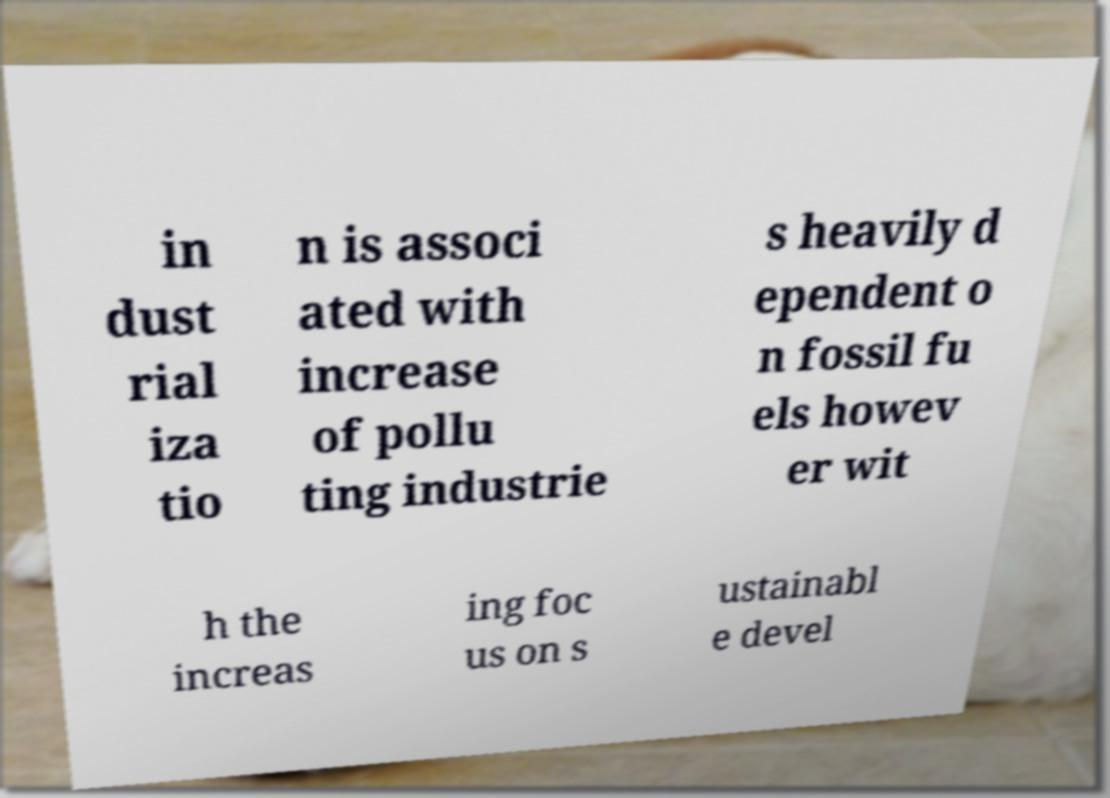Please read and relay the text visible in this image. What does it say? in dust rial iza tio n is associ ated with increase of pollu ting industrie s heavily d ependent o n fossil fu els howev er wit h the increas ing foc us on s ustainabl e devel 